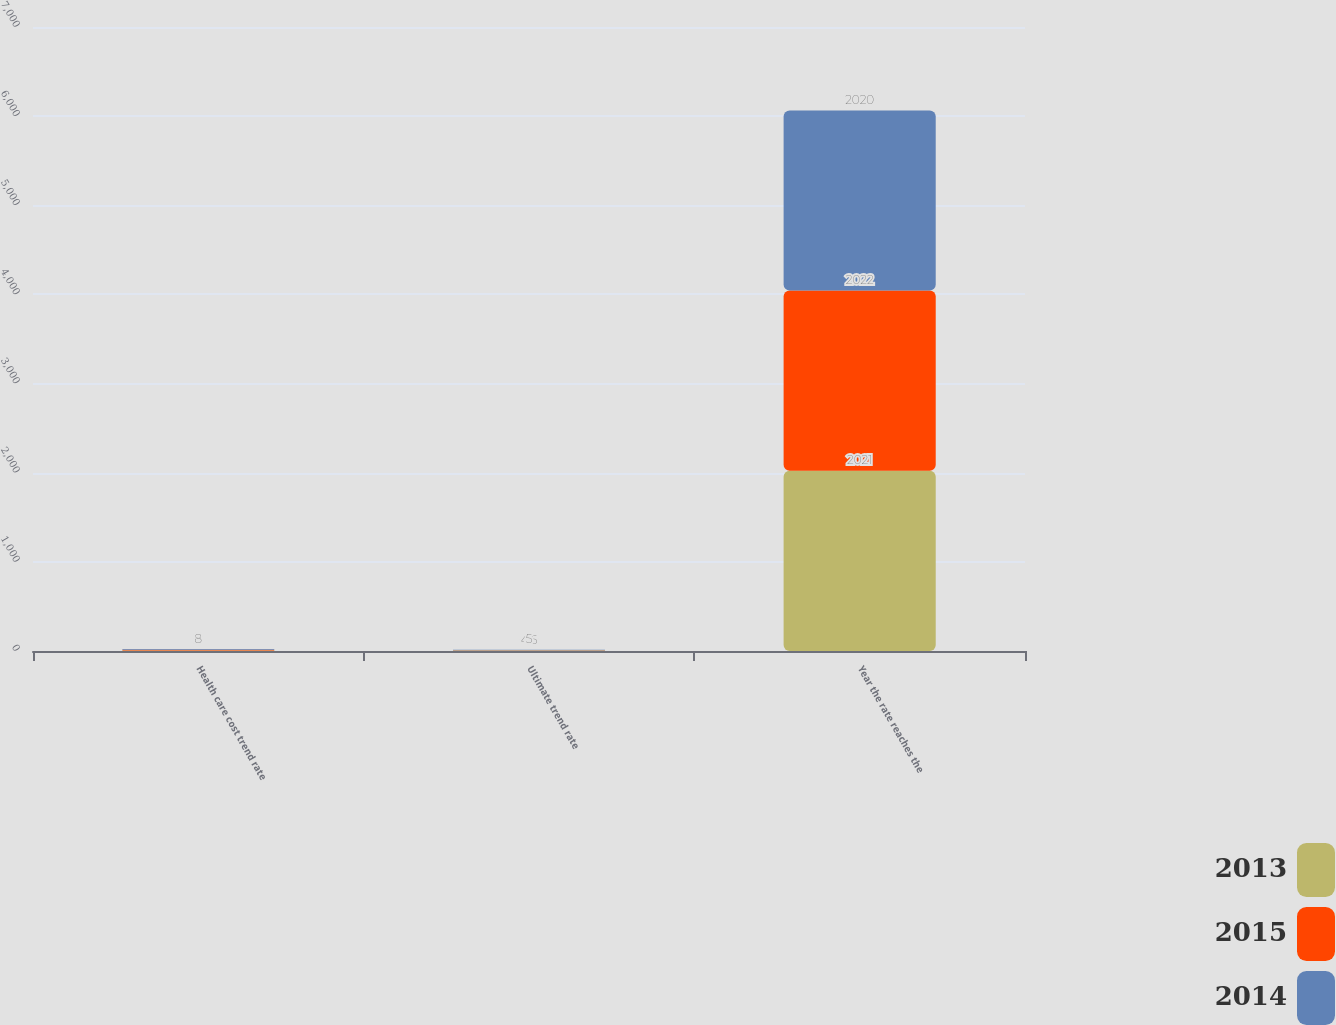Convert chart to OTSL. <chart><loc_0><loc_0><loc_500><loc_500><stacked_bar_chart><ecel><fcel>Health care cost trend rate<fcel>Ultimate trend rate<fcel>Year the rate reaches the<nl><fcel>2013<fcel>6<fcel>4.5<fcel>2021<nl><fcel>2015<fcel>8<fcel>4.5<fcel>2022<nl><fcel>2014<fcel>8<fcel>5<fcel>2020<nl></chart> 